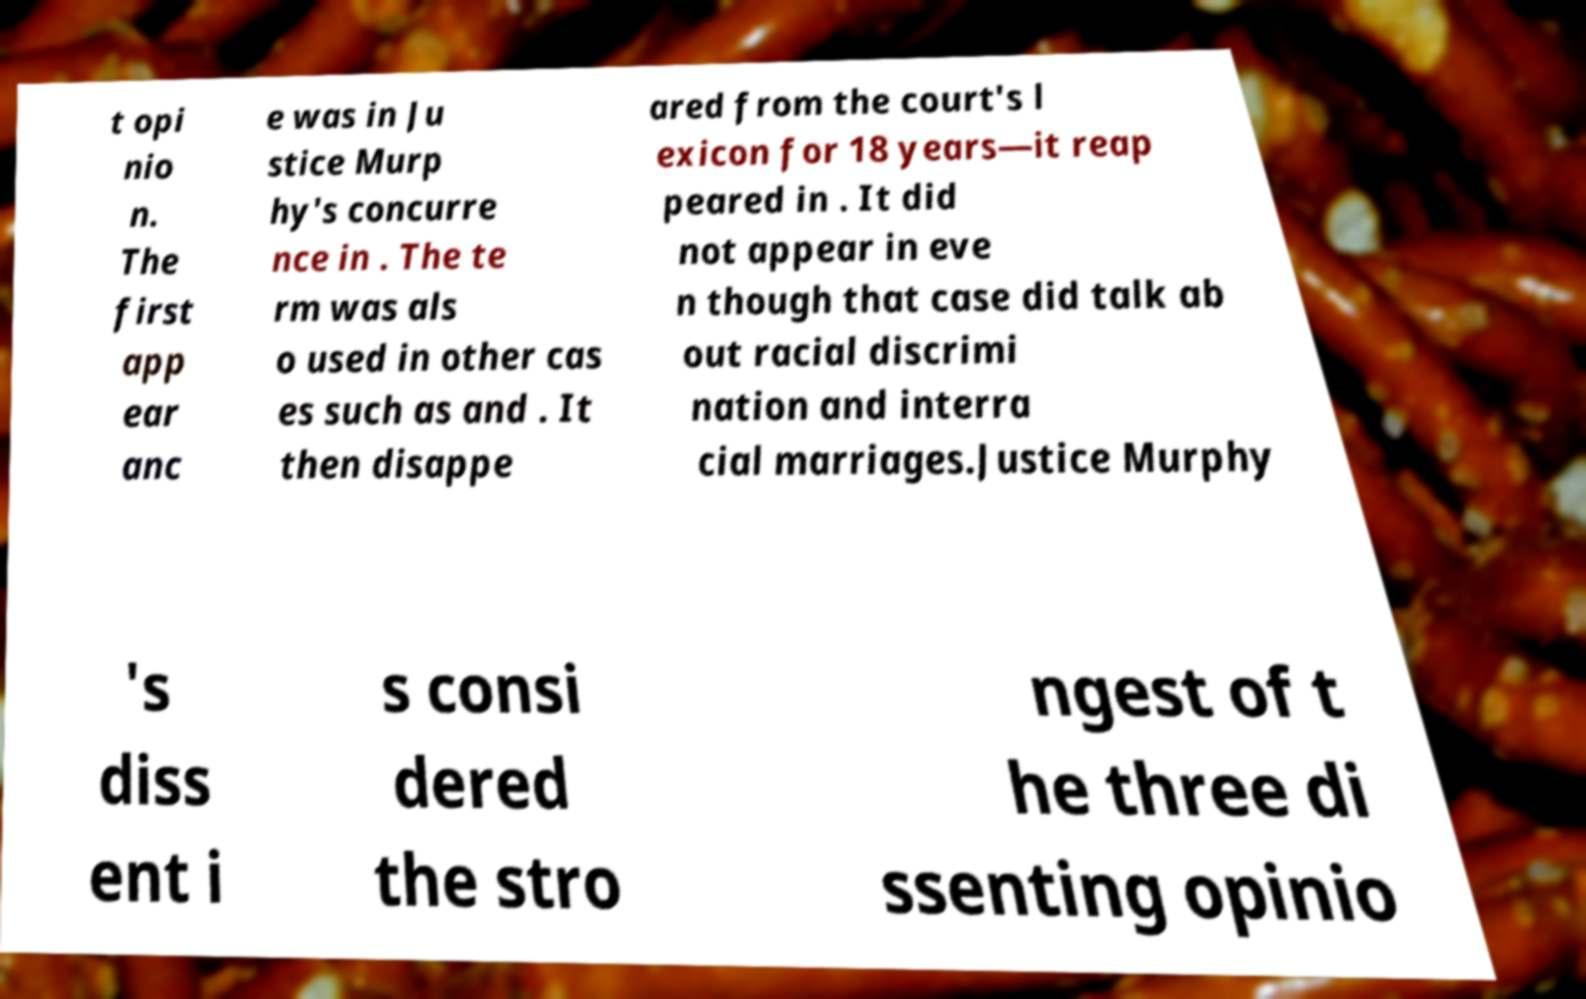Please identify and transcribe the text found in this image. t opi nio n. The first app ear anc e was in Ju stice Murp hy's concurre nce in . The te rm was als o used in other cas es such as and . It then disappe ared from the court's l exicon for 18 years—it reap peared in . It did not appear in eve n though that case did talk ab out racial discrimi nation and interra cial marriages.Justice Murphy 's diss ent i s consi dered the stro ngest of t he three di ssenting opinio 